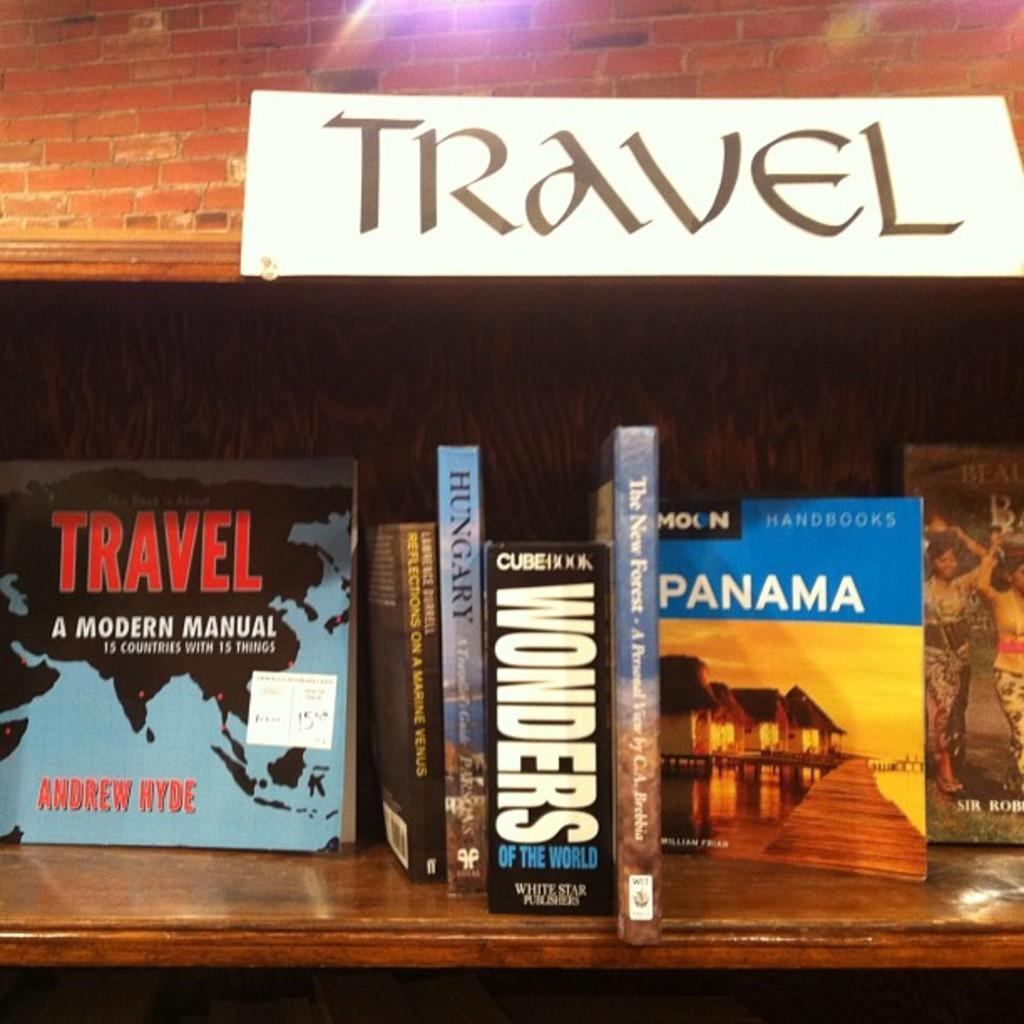<image>
Relay a brief, clear account of the picture shown. Books about travel including one about Panama and Hungary are sitting on a shelf. 